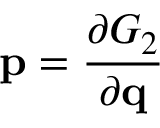<formula> <loc_0><loc_0><loc_500><loc_500>p = { \frac { \partial G _ { 2 } } { \partial q } }</formula> 